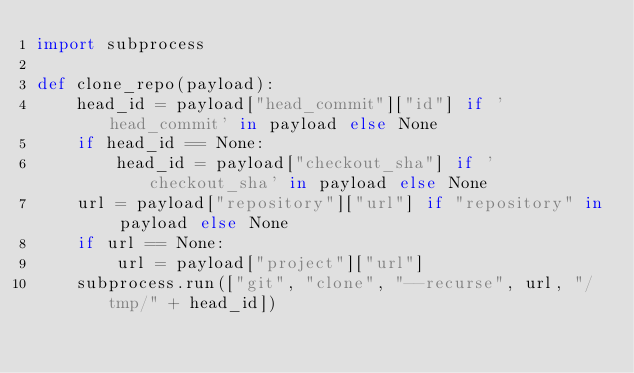Convert code to text. <code><loc_0><loc_0><loc_500><loc_500><_Python_>import subprocess

def clone_repo(payload):
    head_id = payload["head_commit"]["id"] if 'head_commit' in payload else None
    if head_id == None:
        head_id = payload["checkout_sha"] if 'checkout_sha' in payload else None
    url = payload["repository"]["url"] if "repository" in payload else None
    if url == None:
        url = payload["project"]["url"]
    subprocess.run(["git", "clone", "--recurse", url, "/tmp/" + head_id])
</code> 